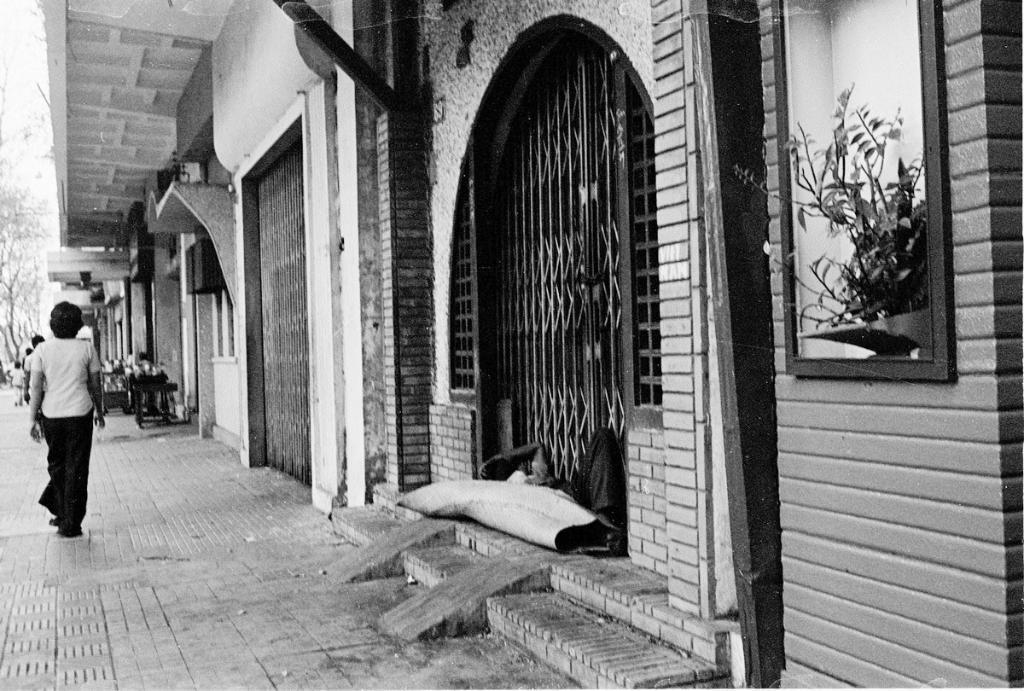How would you summarize this image in a sentence or two? In this picture there are some closed shop with grills. On the left side we can see a woman walking on the footpath area. On the front right side there is a wall with flower pot placed in the window. 